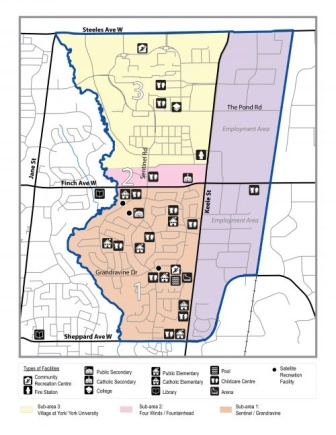What types of public facilities are marked on the map? The map marks several types of public facilities: public elementary schools in yellow, public secondary schools in orange, Catholic elementary schools in pink, Catholic secondary schools in blue, and other facilities such as recreational centers, parks, or community buildings in green. The precise locations of these facilities are clearly indicated, helping users navigate and understand the distribution of public services in the neighborhood. 